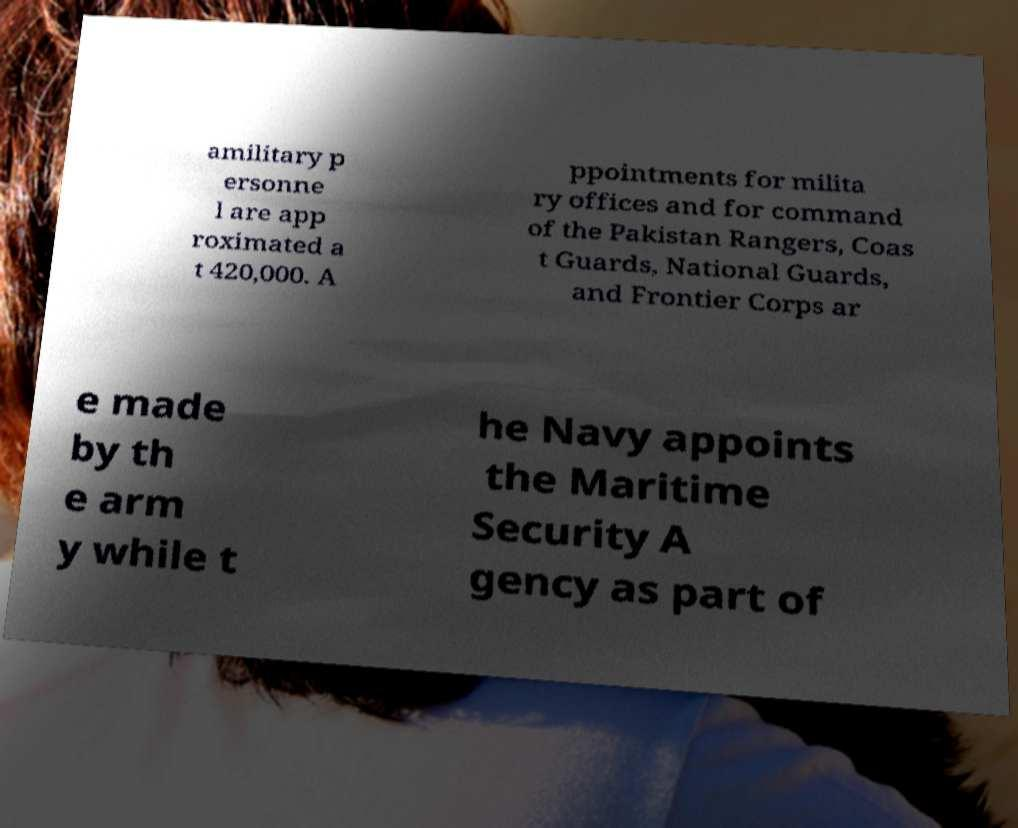Please identify and transcribe the text found in this image. amilitary p ersonne l are app roximated a t 420,000. A ppointments for milita ry offices and for command of the Pakistan Rangers, Coas t Guards, National Guards, and Frontier Corps ar e made by th e arm y while t he Navy appoints the Maritime Security A gency as part of 